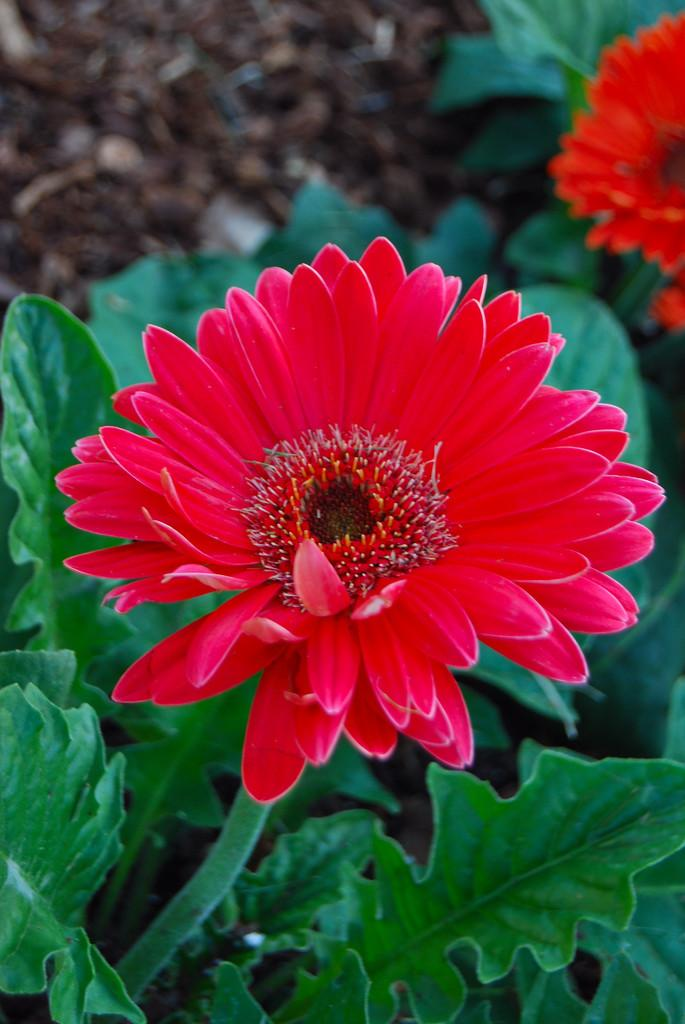What type of living organisms can be seen in the image? Flowers and plants are visible in the image. Can you describe the plants in the image? The image contains flowers, which are a type of plant. What is the scent of the flowers in the image? The image does not provide information about the scent of the flowers, as it only shows a visual representation. 